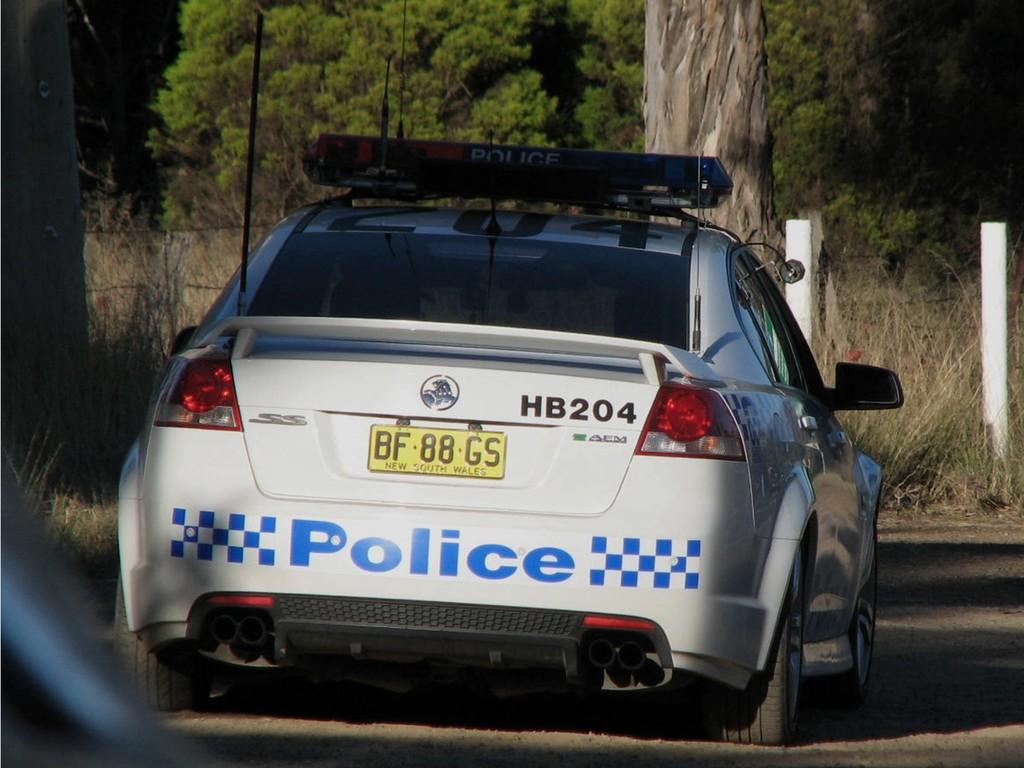Who does the car belong to?
Your response must be concise. Police. 